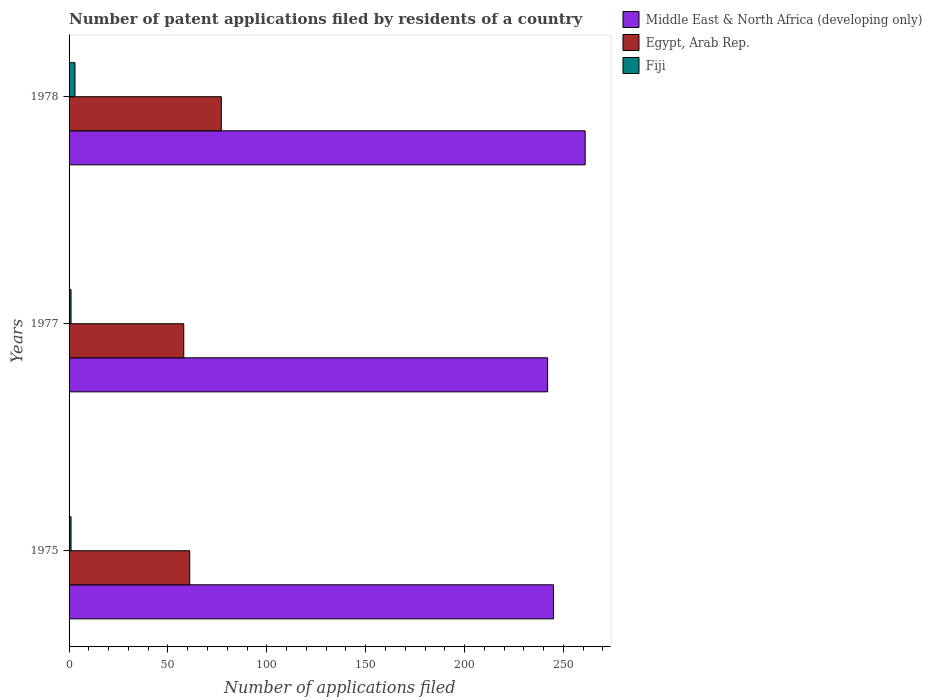How many bars are there on the 3rd tick from the top?
Your response must be concise. 3. How many bars are there on the 1st tick from the bottom?
Provide a succinct answer. 3. What is the number of applications filed in Middle East & North Africa (developing only) in 1978?
Make the answer very short. 261. Across all years, what is the maximum number of applications filed in Middle East & North Africa (developing only)?
Your answer should be very brief. 261. Across all years, what is the minimum number of applications filed in Egypt, Arab Rep.?
Keep it short and to the point. 58. In which year was the number of applications filed in Egypt, Arab Rep. maximum?
Keep it short and to the point. 1978. What is the total number of applications filed in Fiji in the graph?
Ensure brevity in your answer.  5. What is the difference between the number of applications filed in Middle East & North Africa (developing only) in 1978 and the number of applications filed in Fiji in 1977?
Offer a terse response. 260. What is the average number of applications filed in Fiji per year?
Provide a succinct answer. 1.67. In the year 1977, what is the difference between the number of applications filed in Fiji and number of applications filed in Middle East & North Africa (developing only)?
Ensure brevity in your answer.  -241. What is the ratio of the number of applications filed in Middle East & North Africa (developing only) in 1977 to that in 1978?
Your answer should be very brief. 0.93. What is the difference between the highest and the lowest number of applications filed in Egypt, Arab Rep.?
Give a very brief answer. 19. Is the sum of the number of applications filed in Egypt, Arab Rep. in 1977 and 1978 greater than the maximum number of applications filed in Middle East & North Africa (developing only) across all years?
Provide a succinct answer. No. What does the 2nd bar from the top in 1978 represents?
Keep it short and to the point. Egypt, Arab Rep. What does the 1st bar from the bottom in 1975 represents?
Provide a short and direct response. Middle East & North Africa (developing only). Is it the case that in every year, the sum of the number of applications filed in Egypt, Arab Rep. and number of applications filed in Fiji is greater than the number of applications filed in Middle East & North Africa (developing only)?
Make the answer very short. No. How many bars are there?
Keep it short and to the point. 9. Does the graph contain grids?
Make the answer very short. No. What is the title of the graph?
Your answer should be compact. Number of patent applications filed by residents of a country. What is the label or title of the X-axis?
Your answer should be compact. Number of applications filed. What is the label or title of the Y-axis?
Your answer should be very brief. Years. What is the Number of applications filed of Middle East & North Africa (developing only) in 1975?
Keep it short and to the point. 245. What is the Number of applications filed in Middle East & North Africa (developing only) in 1977?
Make the answer very short. 242. What is the Number of applications filed in Egypt, Arab Rep. in 1977?
Your response must be concise. 58. What is the Number of applications filed in Middle East & North Africa (developing only) in 1978?
Give a very brief answer. 261. What is the Number of applications filed of Egypt, Arab Rep. in 1978?
Provide a succinct answer. 77. Across all years, what is the maximum Number of applications filed of Middle East & North Africa (developing only)?
Your response must be concise. 261. Across all years, what is the minimum Number of applications filed in Middle East & North Africa (developing only)?
Keep it short and to the point. 242. Across all years, what is the minimum Number of applications filed of Egypt, Arab Rep.?
Your answer should be very brief. 58. Across all years, what is the minimum Number of applications filed of Fiji?
Make the answer very short. 1. What is the total Number of applications filed of Middle East & North Africa (developing only) in the graph?
Your response must be concise. 748. What is the total Number of applications filed in Egypt, Arab Rep. in the graph?
Keep it short and to the point. 196. What is the total Number of applications filed of Fiji in the graph?
Offer a terse response. 5. What is the difference between the Number of applications filed of Egypt, Arab Rep. in 1975 and that in 1977?
Offer a very short reply. 3. What is the difference between the Number of applications filed of Fiji in 1975 and that in 1977?
Give a very brief answer. 0. What is the difference between the Number of applications filed of Egypt, Arab Rep. in 1977 and that in 1978?
Provide a succinct answer. -19. What is the difference between the Number of applications filed of Fiji in 1977 and that in 1978?
Your answer should be compact. -2. What is the difference between the Number of applications filed of Middle East & North Africa (developing only) in 1975 and the Number of applications filed of Egypt, Arab Rep. in 1977?
Offer a very short reply. 187. What is the difference between the Number of applications filed of Middle East & North Africa (developing only) in 1975 and the Number of applications filed of Fiji in 1977?
Your response must be concise. 244. What is the difference between the Number of applications filed of Middle East & North Africa (developing only) in 1975 and the Number of applications filed of Egypt, Arab Rep. in 1978?
Provide a succinct answer. 168. What is the difference between the Number of applications filed in Middle East & North Africa (developing only) in 1975 and the Number of applications filed in Fiji in 1978?
Your answer should be very brief. 242. What is the difference between the Number of applications filed of Middle East & North Africa (developing only) in 1977 and the Number of applications filed of Egypt, Arab Rep. in 1978?
Offer a very short reply. 165. What is the difference between the Number of applications filed of Middle East & North Africa (developing only) in 1977 and the Number of applications filed of Fiji in 1978?
Give a very brief answer. 239. What is the difference between the Number of applications filed of Egypt, Arab Rep. in 1977 and the Number of applications filed of Fiji in 1978?
Keep it short and to the point. 55. What is the average Number of applications filed of Middle East & North Africa (developing only) per year?
Offer a very short reply. 249.33. What is the average Number of applications filed in Egypt, Arab Rep. per year?
Provide a succinct answer. 65.33. In the year 1975, what is the difference between the Number of applications filed of Middle East & North Africa (developing only) and Number of applications filed of Egypt, Arab Rep.?
Your answer should be compact. 184. In the year 1975, what is the difference between the Number of applications filed in Middle East & North Africa (developing only) and Number of applications filed in Fiji?
Your answer should be very brief. 244. In the year 1975, what is the difference between the Number of applications filed in Egypt, Arab Rep. and Number of applications filed in Fiji?
Ensure brevity in your answer.  60. In the year 1977, what is the difference between the Number of applications filed of Middle East & North Africa (developing only) and Number of applications filed of Egypt, Arab Rep.?
Make the answer very short. 184. In the year 1977, what is the difference between the Number of applications filed in Middle East & North Africa (developing only) and Number of applications filed in Fiji?
Provide a short and direct response. 241. In the year 1978, what is the difference between the Number of applications filed of Middle East & North Africa (developing only) and Number of applications filed of Egypt, Arab Rep.?
Give a very brief answer. 184. In the year 1978, what is the difference between the Number of applications filed of Middle East & North Africa (developing only) and Number of applications filed of Fiji?
Provide a short and direct response. 258. In the year 1978, what is the difference between the Number of applications filed in Egypt, Arab Rep. and Number of applications filed in Fiji?
Offer a very short reply. 74. What is the ratio of the Number of applications filed of Middle East & North Africa (developing only) in 1975 to that in 1977?
Your response must be concise. 1.01. What is the ratio of the Number of applications filed of Egypt, Arab Rep. in 1975 to that in 1977?
Your response must be concise. 1.05. What is the ratio of the Number of applications filed of Fiji in 1975 to that in 1977?
Offer a terse response. 1. What is the ratio of the Number of applications filed in Middle East & North Africa (developing only) in 1975 to that in 1978?
Your answer should be compact. 0.94. What is the ratio of the Number of applications filed in Egypt, Arab Rep. in 1975 to that in 1978?
Your answer should be compact. 0.79. What is the ratio of the Number of applications filed of Fiji in 1975 to that in 1978?
Offer a very short reply. 0.33. What is the ratio of the Number of applications filed of Middle East & North Africa (developing only) in 1977 to that in 1978?
Offer a very short reply. 0.93. What is the ratio of the Number of applications filed of Egypt, Arab Rep. in 1977 to that in 1978?
Your answer should be very brief. 0.75. What is the difference between the highest and the second highest Number of applications filed of Middle East & North Africa (developing only)?
Offer a very short reply. 16. What is the difference between the highest and the lowest Number of applications filed of Egypt, Arab Rep.?
Provide a succinct answer. 19. 